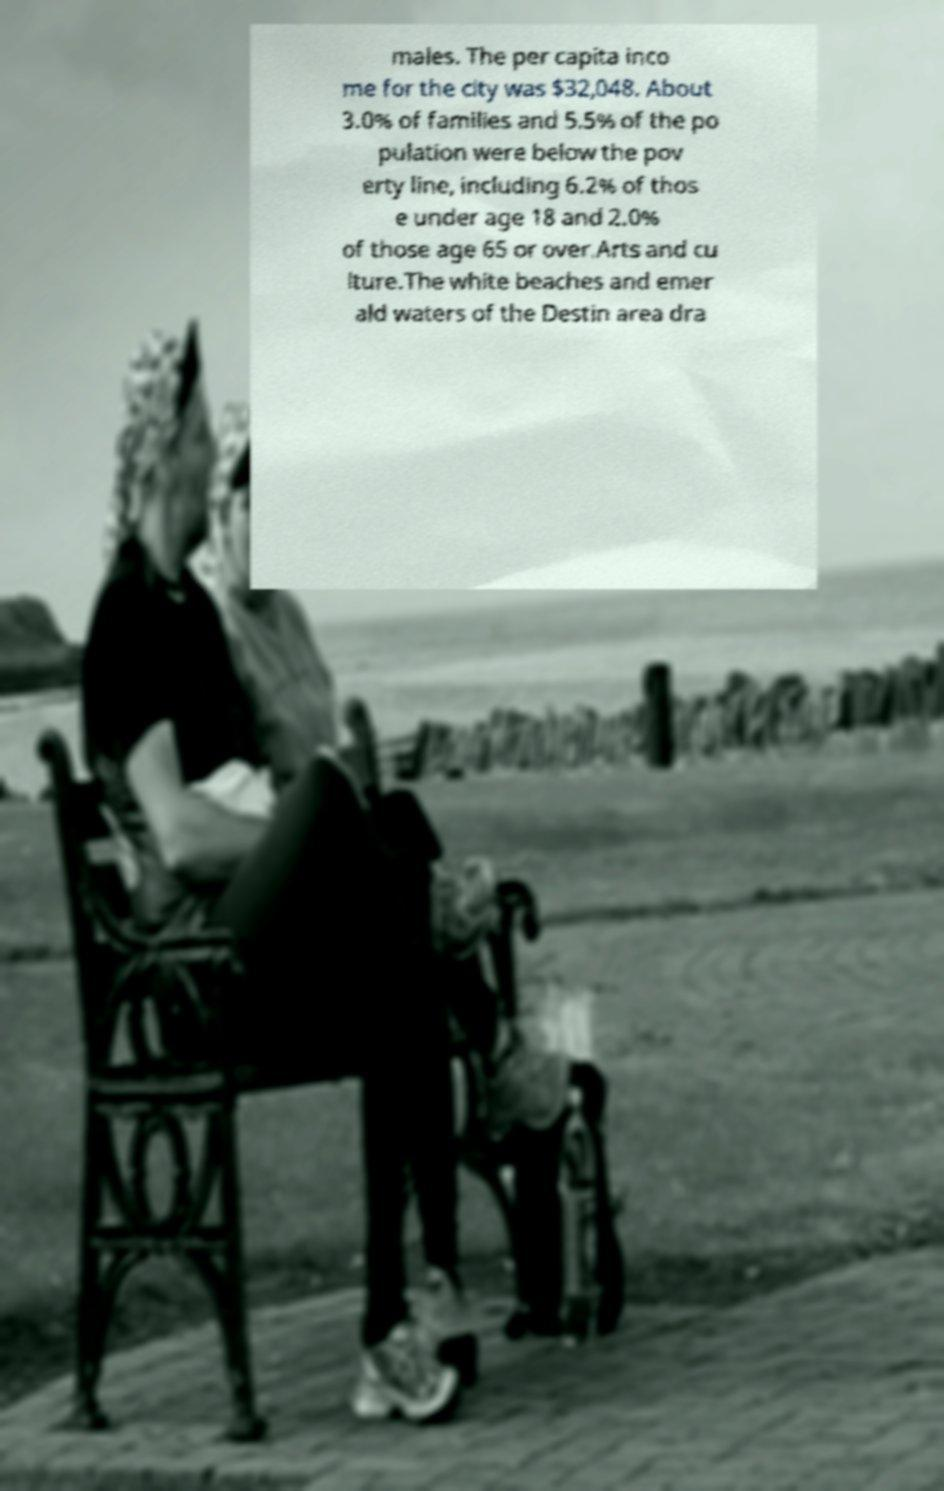For documentation purposes, I need the text within this image transcribed. Could you provide that? males. The per capita inco me for the city was $32,048. About 3.0% of families and 5.5% of the po pulation were below the pov erty line, including 6.2% of thos e under age 18 and 2.0% of those age 65 or over.Arts and cu lture.The white beaches and emer ald waters of the Destin area dra 